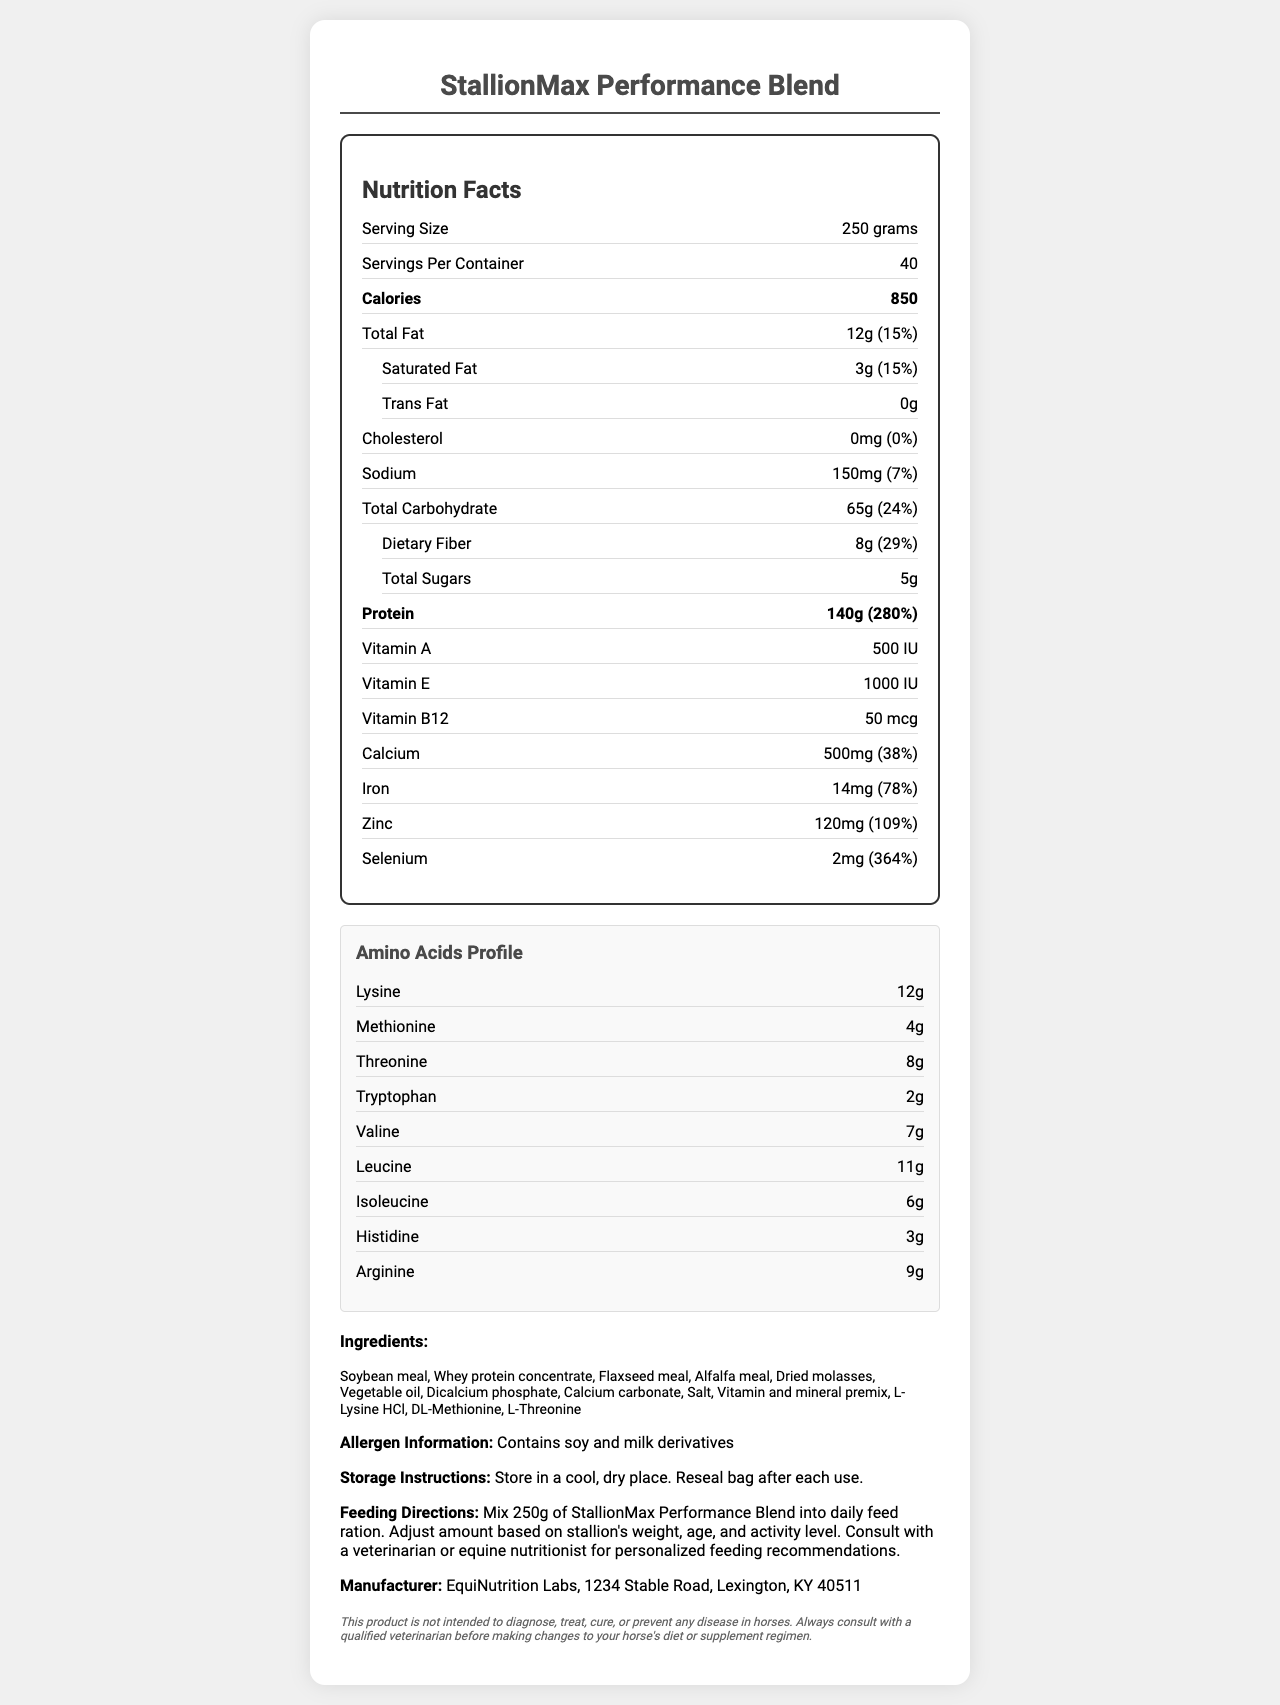how many servings are there per container? The "Servings Per Container" is listed as 40 on the document.
Answer: 40 what is the serving size of StallionMax Performance Blend? The "Serving Size" is mentioned as 250 grams on the Nutrition Facts Label.
Answer: 250 grams how many calories per serving does StallionMax Performance Blend provide? The "Calories" section indicates that each serving contains 850 calories.
Answer: 850 what is the total amount of protein per serving and its daily value percentage? The document states that StallionMax Performance Blend contains 140g of protein per serving, which is 280% of the daily value.
Answer: 140g, 280% what ingredients are listed in StallionMax Performance Blend? The "Ingredients" section provides a list of all the ingredients in the supplement.
Answer: Soybean meal, Whey protein concentrate, Flaxseed meal, Alfalfa meal, Dried molasses, Vegetable oil, Dicalcium phosphate, Calcium carbonate, Salt, Vitamin and mineral premix, L-Lysine HCl, DL-Methionine, L-Threonine what is the amount of dietary fiber per serving? The "Dietary Fiber" amount per serving is listed as 8 grams.
Answer: 8g which vitamin is present in the highest amount in StallionMax Performance Blend? A. Vitamin A B. Vitamin E C. Vitamin B12 Vitamin E is present in the highest amount at 1000 IU compared to Vitamin A at 500 IU and Vitamin B12 at 50 mcg.
Answer: B how much selenium is in each serving? A. 1mg B. 2mg C. 3mg D. 4mg The "Selenium" amount per serving is listed as 2 mg.
Answer: B is StallionMax Performance Blend suitable for horses allergic to soy or milk? The "Allergen Information" mentions that the product contains soy and milk derivatives, making it unsuitable for horses with allergies to these substances.
Answer: No does StallionMax Performance Blend contain any cholesterol? The "Cholesterol" section indicates that the amount is 0mg, which means it contains no cholesterol.
Answer: No what is the main purpose of the document? The document lists the nutritional facts, ingredients, amino acid profile, allergen information, storage instructions, feeding directions, and manufacturer information for StallionMax Performance Blend.
Answer: To provide detailed nutritional information about the StallionMax Performance Blend supplement for stallions. what are the recommended storage instructions for StallionMax Performance Blend? The "Storage Instructions" section advises to store the product in a cool, dry place and to reseal the bag after each use.
Answer: Store in a cool, dry place. Reseal bag after each use. can the exact quantity of vegetable oil in the product be determined from the document? While vegetable oil is listed as an ingredient, the exact quantity is not provided in the document.
Answer: Cannot be determined 